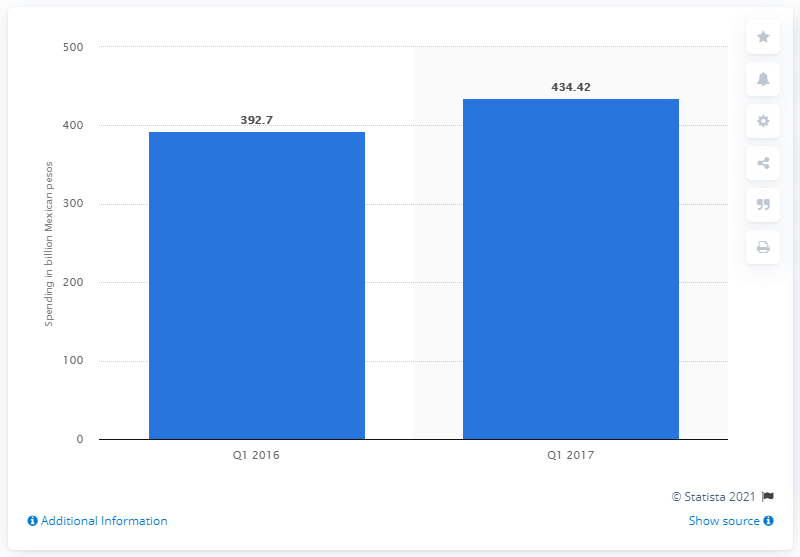Outline some significant characteristics in this image. In the first quarter of 2017, Mexico spent 434.42 on federal spending. 